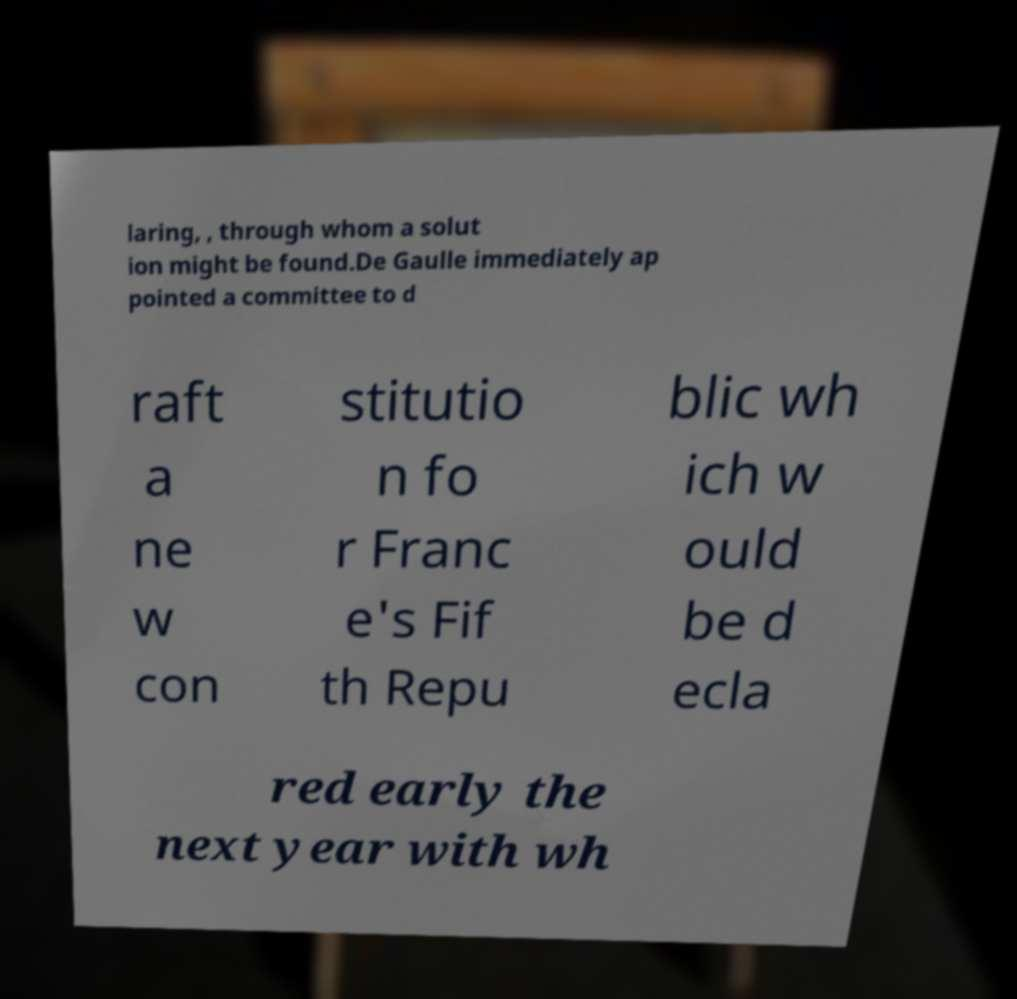Could you extract and type out the text from this image? laring, , through whom a solut ion might be found.De Gaulle immediately ap pointed a committee to d raft a ne w con stitutio n fo r Franc e's Fif th Repu blic wh ich w ould be d ecla red early the next year with wh 